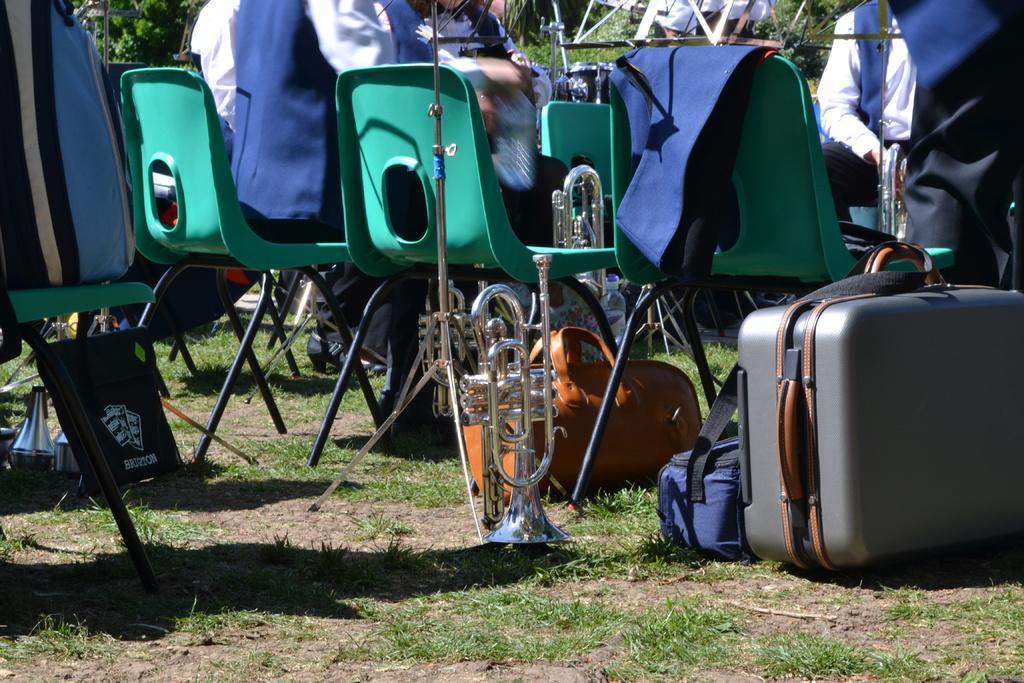Describe this image in one or two sentences. In this image, group of people are sat on the chairs. On right side, we can see luggage, bags, musical instrument. At the bottom, we can see grass. 